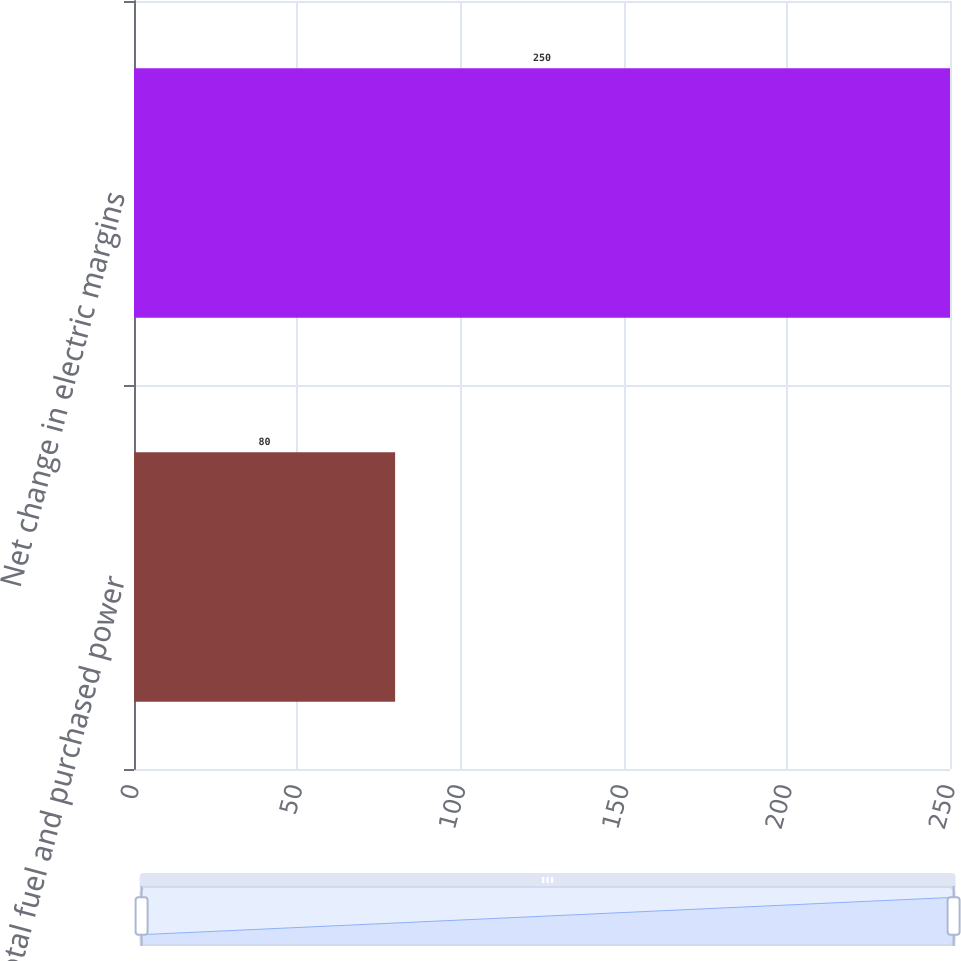Convert chart. <chart><loc_0><loc_0><loc_500><loc_500><bar_chart><fcel>Total fuel and purchased power<fcel>Net change in electric margins<nl><fcel>80<fcel>250<nl></chart> 